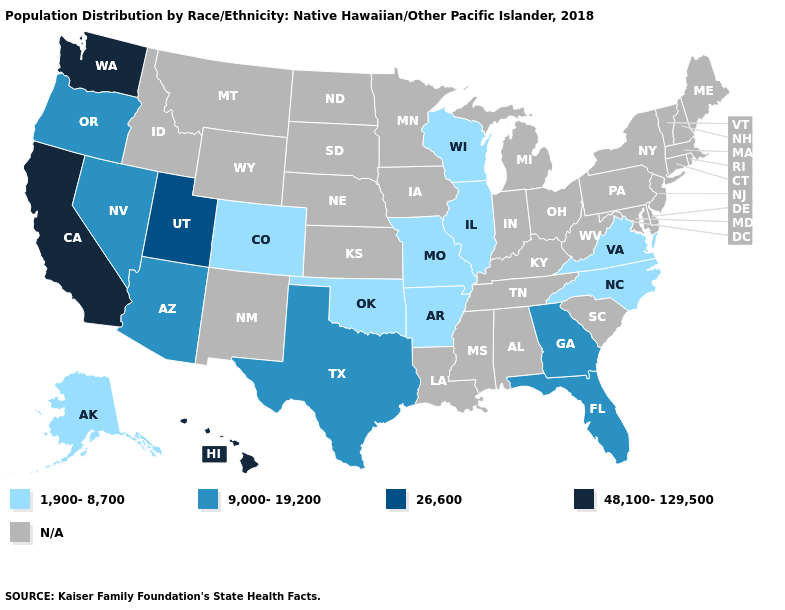Name the states that have a value in the range 26,600?
Write a very short answer. Utah. What is the value of Ohio?
Quick response, please. N/A. Does California have the highest value in the USA?
Short answer required. Yes. Name the states that have a value in the range N/A?
Be succinct. Alabama, Connecticut, Delaware, Idaho, Indiana, Iowa, Kansas, Kentucky, Louisiana, Maine, Maryland, Massachusetts, Michigan, Minnesota, Mississippi, Montana, Nebraska, New Hampshire, New Jersey, New Mexico, New York, North Dakota, Ohio, Pennsylvania, Rhode Island, South Carolina, South Dakota, Tennessee, Vermont, West Virginia, Wyoming. Does Alaska have the highest value in the West?
Write a very short answer. No. Which states have the highest value in the USA?
Concise answer only. California, Hawaii, Washington. What is the value of Mississippi?
Give a very brief answer. N/A. Does Oklahoma have the lowest value in the South?
Short answer required. Yes. What is the lowest value in the MidWest?
Give a very brief answer. 1,900-8,700. Does Washington have the highest value in the USA?
Answer briefly. Yes. What is the lowest value in the West?
Answer briefly. 1,900-8,700. Does North Carolina have the lowest value in the South?
Quick response, please. Yes. Among the states that border Virginia , which have the lowest value?
Write a very short answer. North Carolina. Does the map have missing data?
Keep it brief. Yes. 